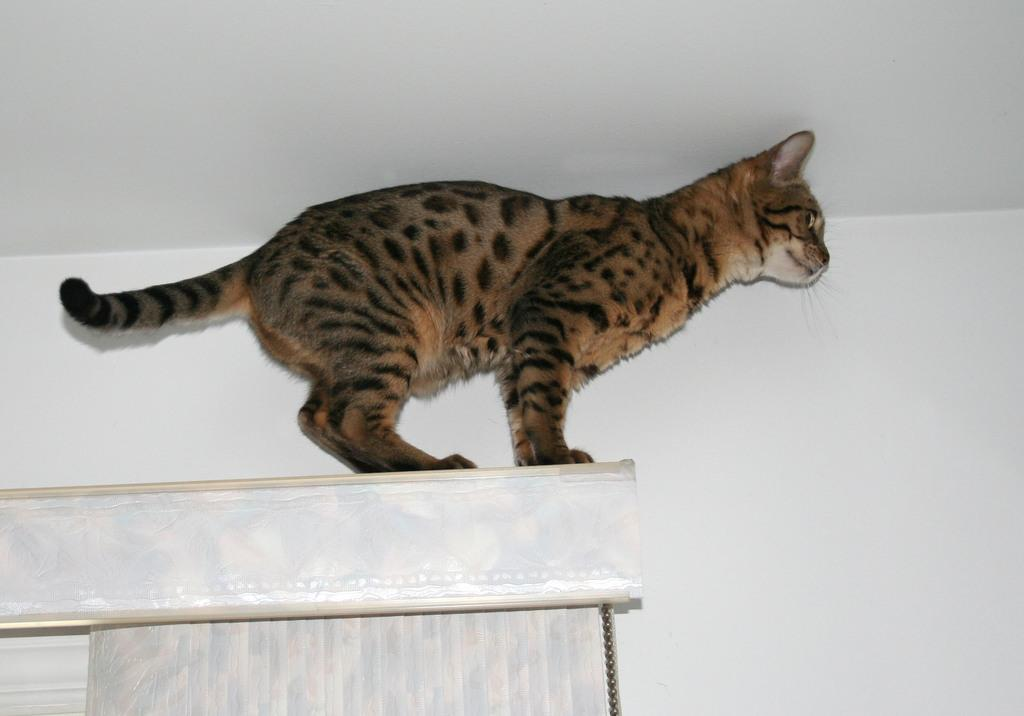What type of animal can be seen in the image? There is a cat in the image. What architectural feature is present in the image? There is a window in the image. What is used to control the amount of light entering the room through the window? There is a blind associated with the window. What is the background of the image made of? There is a wall in the image. Where might this image have been taken? The image may have been taken in a room. What type of vegetable is the cat holding in the image? There is no vegetable present in the image, and the cat is not holding anything. 